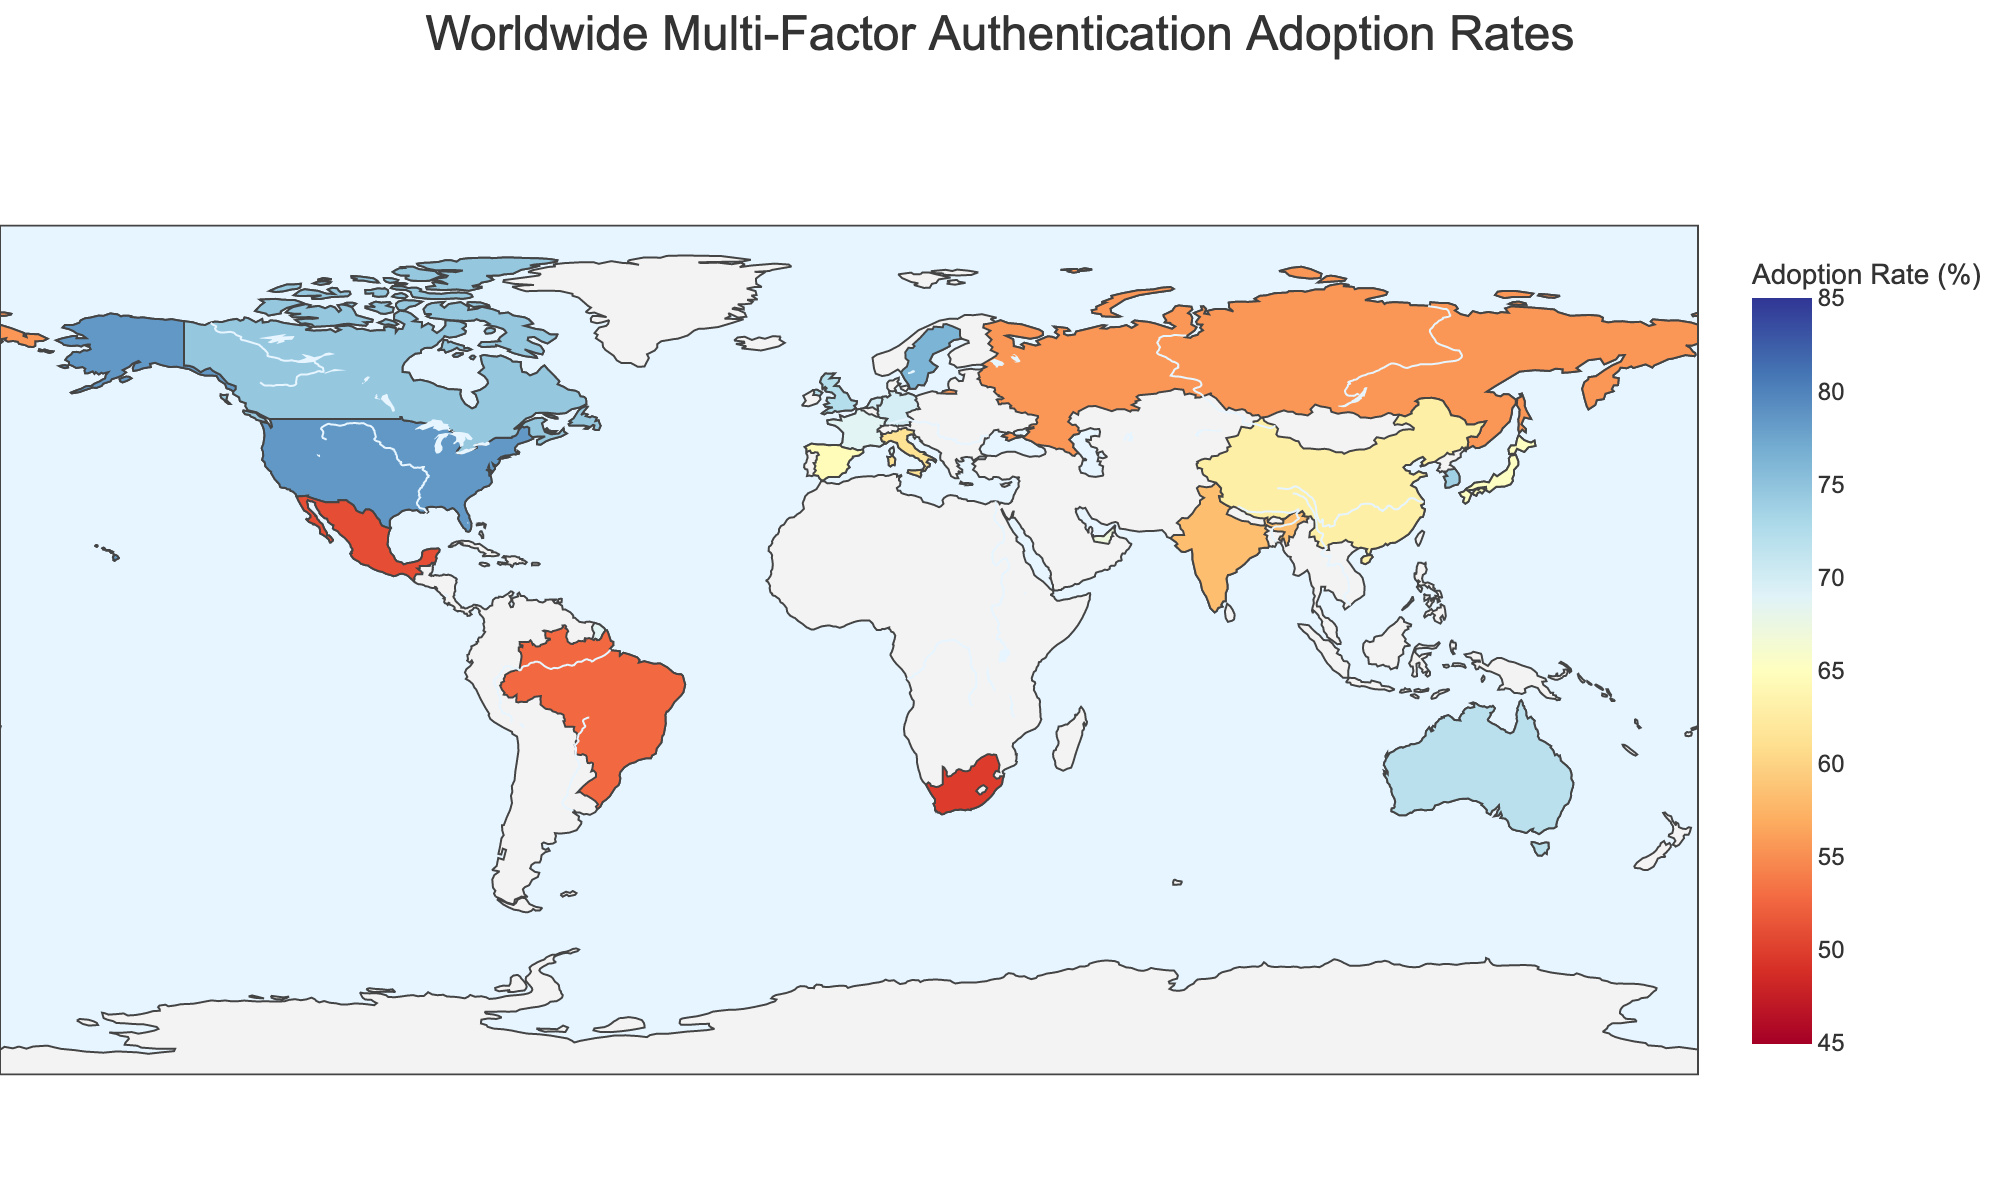What is the title of the plot? The title is the main heading of the plot, usually located at the top center. Look at the top of the plot to find it.
Answer: Worldwide Multi-Factor Authentication Adoption Rates Which country has the highest MFA adoption rate? Check the color gradient and hover over the countries to see their specific MFA adoption rates. Identify the country with the darkest shade corresponding to the highest number.
Answer: Singapore How many countries have an MFA adoption rate over 70%? Count the number of countries with adoption rates greater than 70% by looking at the colors and hovering over the countries to see their exact rates.
Answer: 8 What is the range of MFA adoption rates displayed in the plot? The range can be determined by looking at the color bar legend, which shows the minimum and maximum values.
Answer: 45% to 85% Which countries have an adoption rate below 60%? Identify the countries with lighter shades and hover over them to find those with rates lower than 60%.
Answer: India, Brazil, South Africa, Russia, Mexico What's the average MFA adoption rate across all listed countries? Add up all the MFA adoption rates and divide by the number of countries to find the average. Calculation: (sum of all MFA rates) / 20.
Answer: 65.215 Compare the MFA adoption rates of the United States and China. Which one has a higher rate? Check the rates provided in the plot for both countries and compare them directly.
Answer: United States Which region (e.g., North America, Europe, Asia) seems to have higher MFA adoption rates overall? By looking at the colors and hovering over countries in different regions, you can gauge which region generally has darker shades that indicate higher rates.
Answer: North America What is the adoption rate of MFA in Germany, and how does it compare to the adoption rate in France? Check the adoption rates for Germany and France in the plot and compare the two values directly.
Answer: Germany: 69.8%, France: 68.7% How does the MFA adoption rate in Mexico compare to the average MFA adoption rate across all countries? First, find Mexico's rate, then compare it to the calculated average MFA adoption rate.
Answer: Mexico: 50.9%, Average: 65.215 